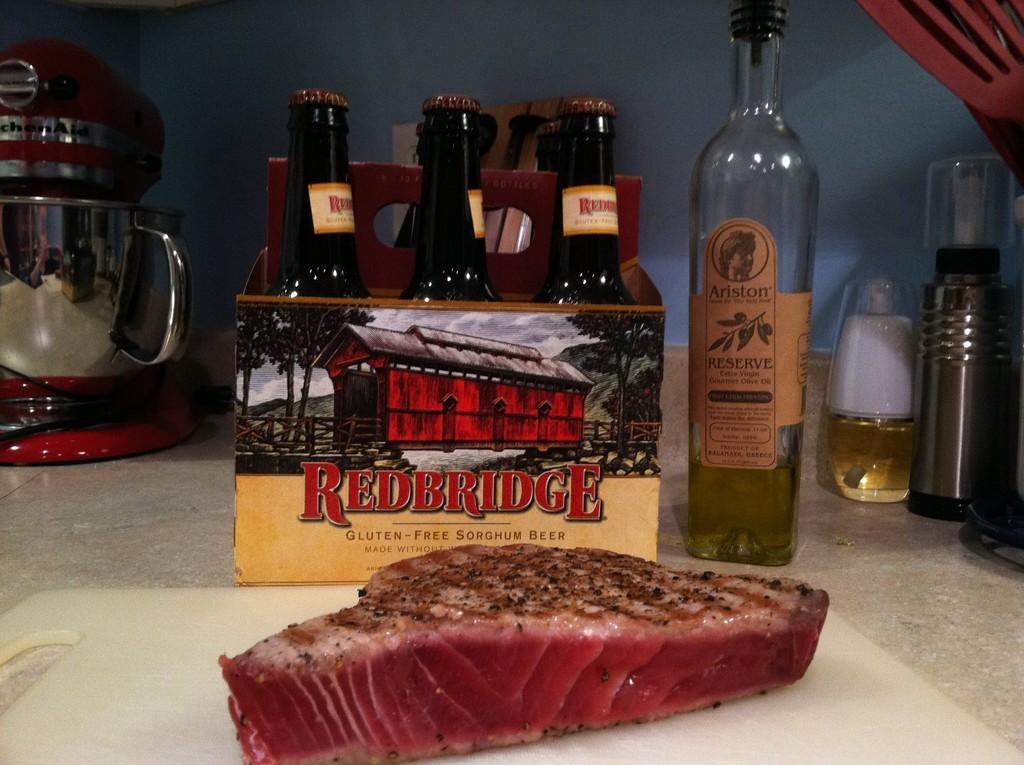<image>
Write a terse but informative summary of the picture. A six pack of Redbridge beer and a bottle of Arison Reserve sit on a countertop behind a cut of meat. 